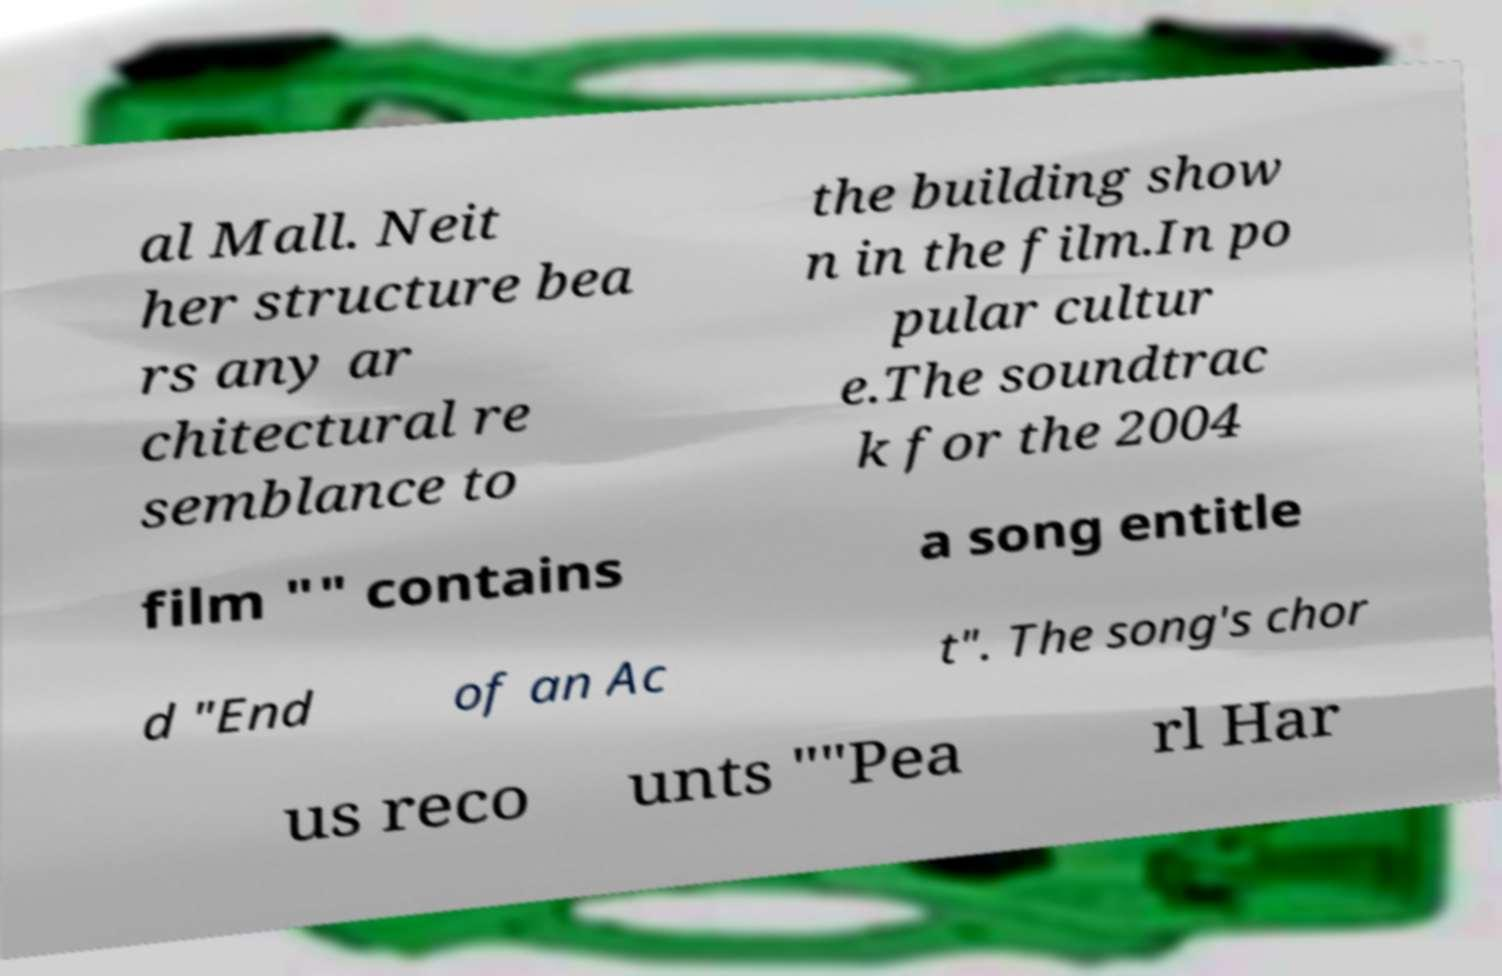Could you assist in decoding the text presented in this image and type it out clearly? al Mall. Neit her structure bea rs any ar chitectural re semblance to the building show n in the film.In po pular cultur e.The soundtrac k for the 2004 film "" contains a song entitle d "End of an Ac t". The song's chor us reco unts ""Pea rl Har 